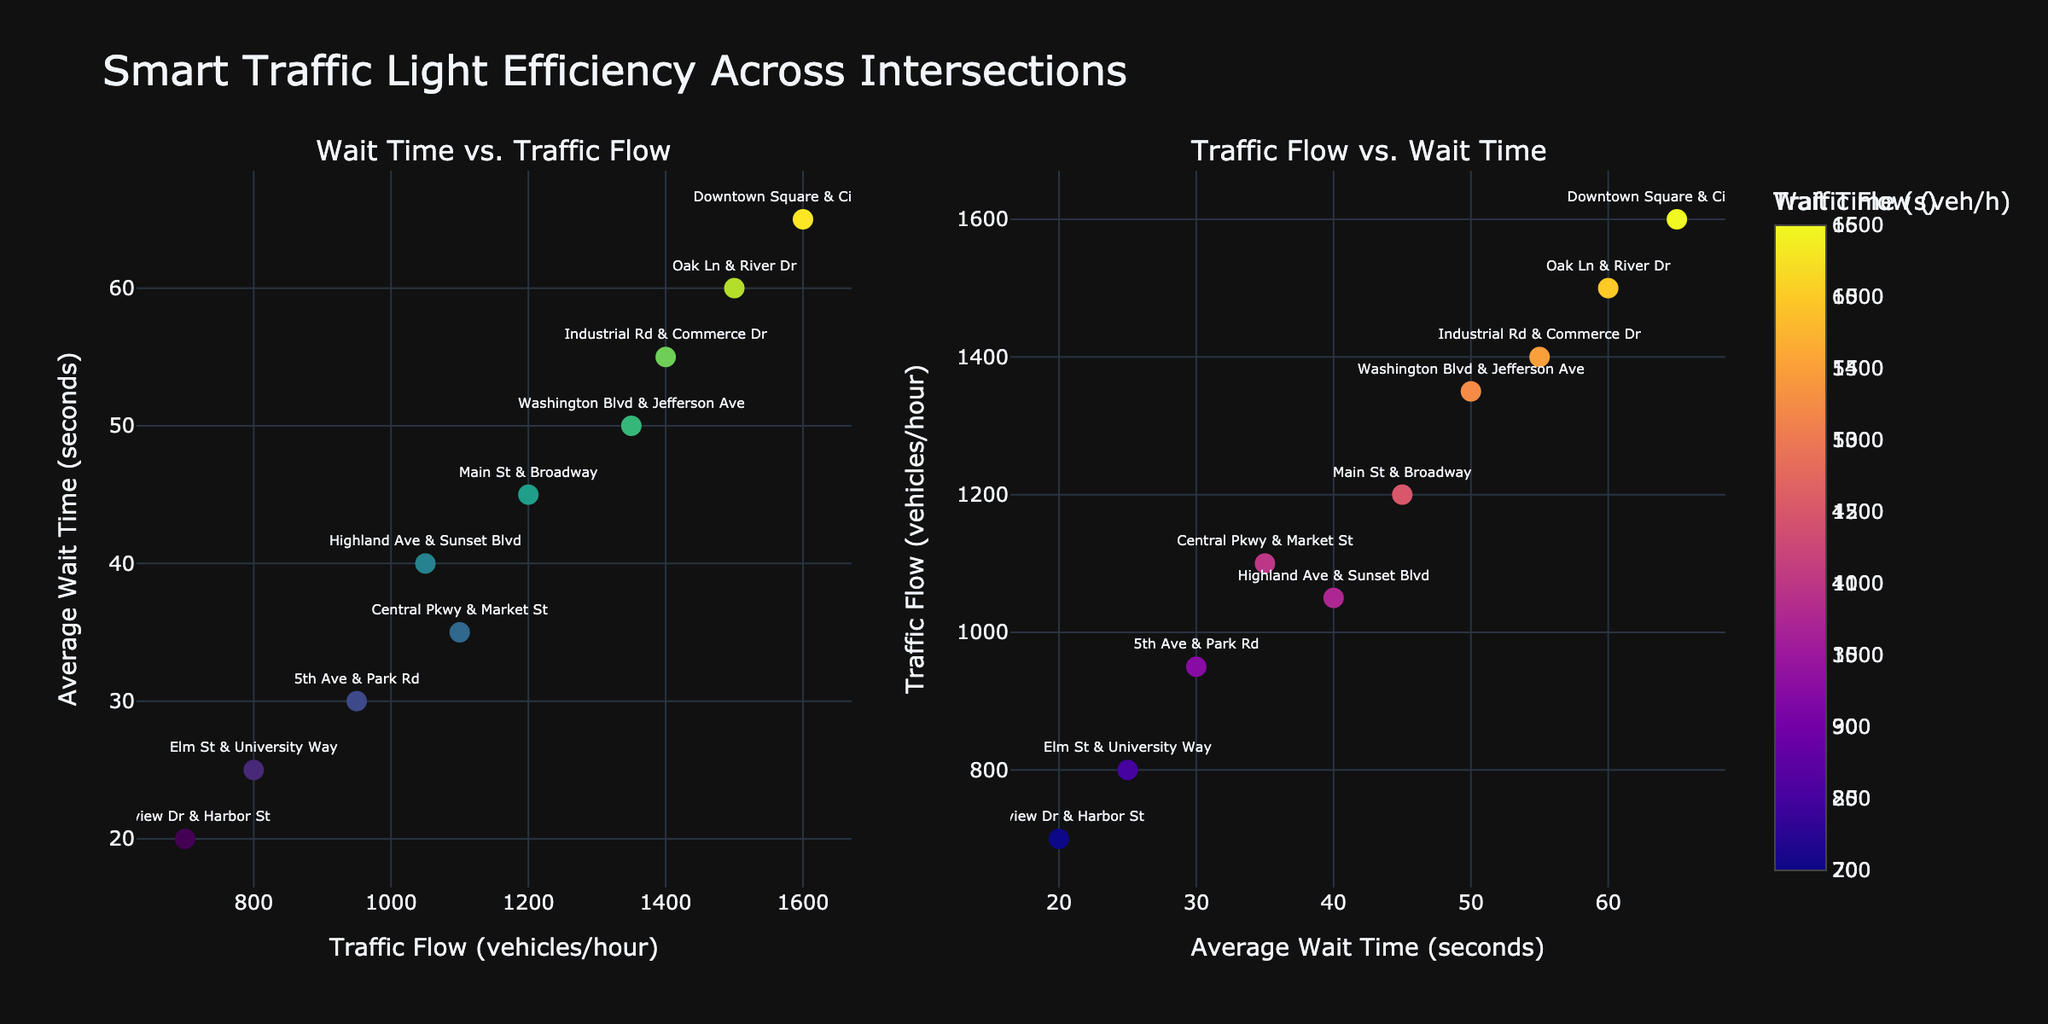Which renewable energy source had the highest adoption rate in 2021? Look at the subplot titles and compare the bar heights for 2021 across all subplots. The 'Hydro' subplot has the highest bar.
Answer: Hydro What is the trend in solar energy adoption from 2015 to 2021? Examine the bars in the 'Solar' subplot from 2015 to 2021. The bars increase in height each year, showing a rising trend.
Answer: Increasing How many different years are displayed on the x-axis? Count the number of distinct ticks on the x-axis in the 'Solar' subplot. Each subplot has the same x-axis. There are 7 ticks corresponding to years from 2015 to 2021.
Answer: 7 Which energy source shows the least change in adoption rate from 2015 to 2021? Compare the height of the bars for each energy source from 2015 to 2021. The 'Geothermal' subplot shows very little change.
Answer: Geothermal Between wind and biomass energy, which had a higher adoption rate in 2020? Locate the bars for 2020 in the 'Wind' and 'Biomass' subplots. The 'Wind' bar is higher than the 'Biomass' bar for 2020.
Answer: Wind By how much did the adoption rate of solar energy increase from 2016 to 2021? Subtract the height of the 2016 bar from the height of the 2021 bar in the 'Solar' subplot. 3.9 - 1.5 = 2.4%.
Answer: 2.4% What is the average adoption rate of hydro energy over the years displayed? Sum the adoption rates of hydro energy from 2015 to 2021 and divide by the number of years (7). (16.6 + 16.8 + 16.7 + 16.9 + 16.8 + 16.8 + 16.9) / 7 = 16.786%.
Answer: 16.8% Which year saw the largest increase in wind energy adoption rate compared to the previous year? Find the differences between consecutive years for the 'Wind' subplot and identify the largest increase. The increase from 2018 (5.1) to 2019 (5.9) is the largest, with a difference of 0.8.
Answer: 2019 Are the adoption rates for biomass energy consistent over the years? Check the heights of the bars in the 'Biomass' subplot across all years. The bars gradually increase each year from 2015 to 2021, showing a consistent upward trend.
Answer: Yes 